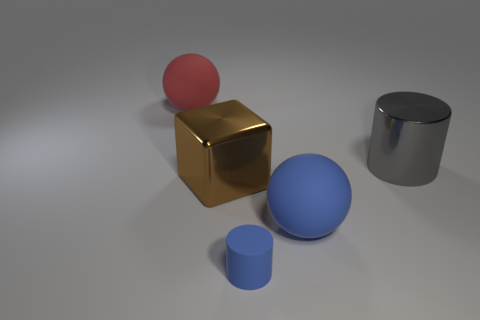Subtract all balls. How many objects are left? 3 Subtract 2 spheres. How many spheres are left? 0 Add 4 large blocks. How many objects exist? 9 Subtract all green cubes. Subtract all green cylinders. How many cubes are left? 1 Subtract all brown balls. How many yellow blocks are left? 0 Subtract all objects. Subtract all red metal blocks. How many objects are left? 0 Add 3 matte spheres. How many matte spheres are left? 5 Add 4 red matte things. How many red matte things exist? 5 Subtract 0 blue blocks. How many objects are left? 5 